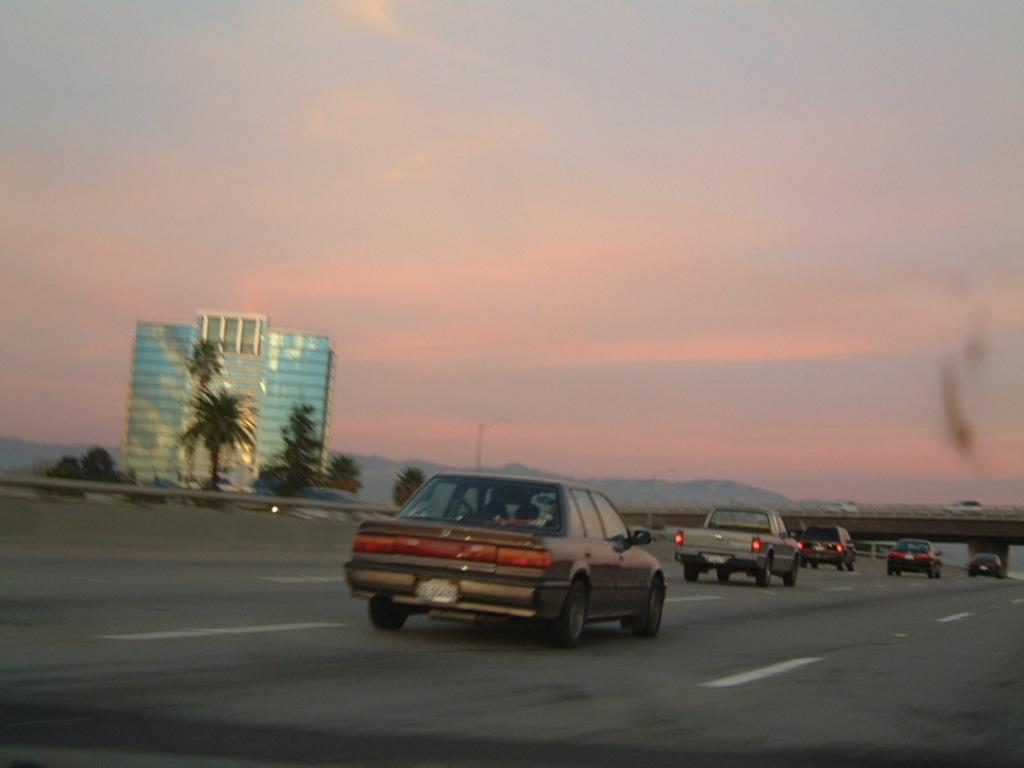What is the main feature of the image? There is a road in the image. What is happening on the road? There are vehicles on the road. What structure can be seen in the image? There is a bridge in the image. What can be seen in the background of the image? There is a building, trees, and the sky visible in the background. Where can the honey be found in the image? There is no honey present in the image. What type of tooth is visible in the image? There are no teeth or tooth-related objects present in the image. 